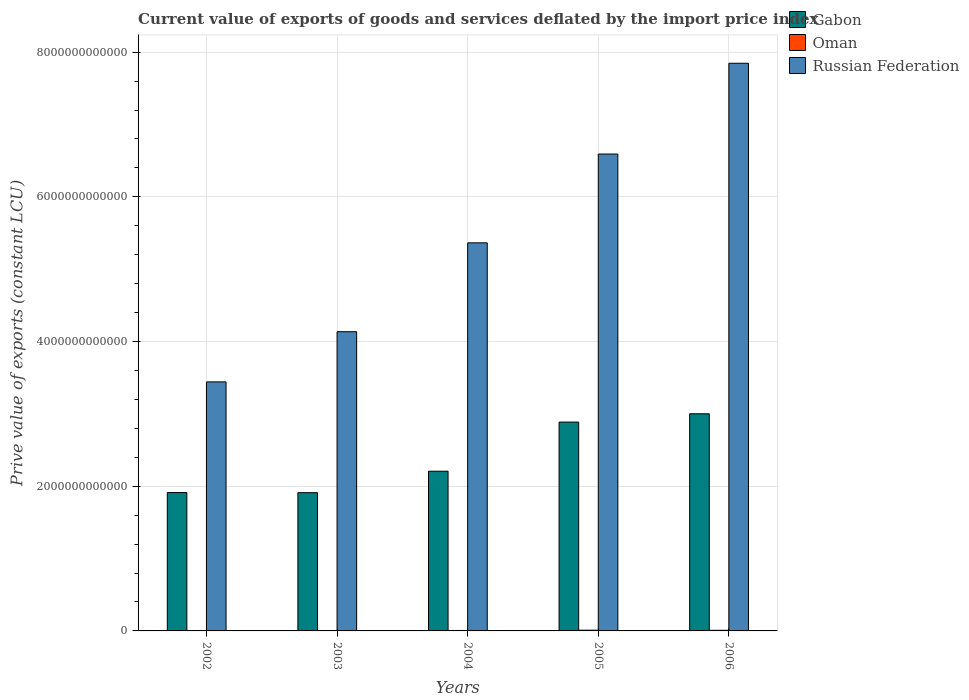How many different coloured bars are there?
Ensure brevity in your answer.  3. Are the number of bars per tick equal to the number of legend labels?
Your answer should be compact. Yes. Are the number of bars on each tick of the X-axis equal?
Your response must be concise. Yes. How many bars are there on the 1st tick from the left?
Your answer should be very brief. 3. What is the label of the 1st group of bars from the left?
Your answer should be compact. 2002. In how many cases, is the number of bars for a given year not equal to the number of legend labels?
Keep it short and to the point. 0. What is the prive value of exports in Russian Federation in 2004?
Your answer should be compact. 5.36e+12. Across all years, what is the maximum prive value of exports in Oman?
Offer a very short reply. 9.95e+09. Across all years, what is the minimum prive value of exports in Gabon?
Your answer should be very brief. 1.91e+12. In which year was the prive value of exports in Gabon maximum?
Your answer should be compact. 2006. What is the total prive value of exports in Gabon in the graph?
Offer a terse response. 1.19e+13. What is the difference between the prive value of exports in Russian Federation in 2002 and that in 2006?
Your answer should be very brief. -4.40e+12. What is the difference between the prive value of exports in Oman in 2005 and the prive value of exports in Gabon in 2002?
Your response must be concise. -1.90e+12. What is the average prive value of exports in Oman per year?
Your response must be concise. 7.17e+09. In the year 2003, what is the difference between the prive value of exports in Oman and prive value of exports in Gabon?
Ensure brevity in your answer.  -1.91e+12. What is the ratio of the prive value of exports in Oman in 2002 to that in 2005?
Offer a terse response. 0.53. Is the prive value of exports in Gabon in 2003 less than that in 2004?
Your answer should be very brief. Yes. Is the difference between the prive value of exports in Oman in 2003 and 2005 greater than the difference between the prive value of exports in Gabon in 2003 and 2005?
Offer a terse response. Yes. What is the difference between the highest and the second highest prive value of exports in Oman?
Give a very brief answer. 1.43e+09. What is the difference between the highest and the lowest prive value of exports in Gabon?
Provide a succinct answer. 1.09e+12. In how many years, is the prive value of exports in Gabon greater than the average prive value of exports in Gabon taken over all years?
Your answer should be compact. 2. What does the 3rd bar from the left in 2006 represents?
Give a very brief answer. Russian Federation. What does the 2nd bar from the right in 2002 represents?
Your response must be concise. Oman. Is it the case that in every year, the sum of the prive value of exports in Russian Federation and prive value of exports in Gabon is greater than the prive value of exports in Oman?
Make the answer very short. Yes. How many bars are there?
Provide a short and direct response. 15. What is the difference between two consecutive major ticks on the Y-axis?
Your answer should be very brief. 2.00e+12. Does the graph contain any zero values?
Your answer should be compact. No. Does the graph contain grids?
Make the answer very short. Yes. Where does the legend appear in the graph?
Your answer should be very brief. Top right. What is the title of the graph?
Provide a short and direct response. Current value of exports of goods and services deflated by the import price index. What is the label or title of the Y-axis?
Your answer should be compact. Prive value of exports (constant LCU). What is the Prive value of exports (constant LCU) in Gabon in 2002?
Keep it short and to the point. 1.91e+12. What is the Prive value of exports (constant LCU) in Oman in 2002?
Your answer should be compact. 5.25e+09. What is the Prive value of exports (constant LCU) of Russian Federation in 2002?
Offer a terse response. 3.44e+12. What is the Prive value of exports (constant LCU) in Gabon in 2003?
Your response must be concise. 1.91e+12. What is the Prive value of exports (constant LCU) in Oman in 2003?
Offer a terse response. 5.76e+09. What is the Prive value of exports (constant LCU) of Russian Federation in 2003?
Offer a terse response. 4.14e+12. What is the Prive value of exports (constant LCU) in Gabon in 2004?
Offer a terse response. 2.21e+12. What is the Prive value of exports (constant LCU) of Oman in 2004?
Keep it short and to the point. 6.38e+09. What is the Prive value of exports (constant LCU) of Russian Federation in 2004?
Provide a short and direct response. 5.36e+12. What is the Prive value of exports (constant LCU) in Gabon in 2005?
Your answer should be very brief. 2.89e+12. What is the Prive value of exports (constant LCU) in Oman in 2005?
Ensure brevity in your answer.  9.95e+09. What is the Prive value of exports (constant LCU) of Russian Federation in 2005?
Your answer should be very brief. 6.59e+12. What is the Prive value of exports (constant LCU) in Gabon in 2006?
Provide a succinct answer. 3.00e+12. What is the Prive value of exports (constant LCU) of Oman in 2006?
Keep it short and to the point. 8.52e+09. What is the Prive value of exports (constant LCU) of Russian Federation in 2006?
Your answer should be very brief. 7.85e+12. Across all years, what is the maximum Prive value of exports (constant LCU) of Gabon?
Keep it short and to the point. 3.00e+12. Across all years, what is the maximum Prive value of exports (constant LCU) of Oman?
Your answer should be compact. 9.95e+09. Across all years, what is the maximum Prive value of exports (constant LCU) in Russian Federation?
Offer a very short reply. 7.85e+12. Across all years, what is the minimum Prive value of exports (constant LCU) in Gabon?
Keep it short and to the point. 1.91e+12. Across all years, what is the minimum Prive value of exports (constant LCU) of Oman?
Provide a short and direct response. 5.25e+09. Across all years, what is the minimum Prive value of exports (constant LCU) of Russian Federation?
Keep it short and to the point. 3.44e+12. What is the total Prive value of exports (constant LCU) of Gabon in the graph?
Your answer should be compact. 1.19e+13. What is the total Prive value of exports (constant LCU) of Oman in the graph?
Your answer should be very brief. 3.59e+1. What is the total Prive value of exports (constant LCU) in Russian Federation in the graph?
Your answer should be compact. 2.74e+13. What is the difference between the Prive value of exports (constant LCU) of Gabon in 2002 and that in 2003?
Your answer should be very brief. 1.37e+09. What is the difference between the Prive value of exports (constant LCU) of Oman in 2002 and that in 2003?
Provide a short and direct response. -5.11e+08. What is the difference between the Prive value of exports (constant LCU) of Russian Federation in 2002 and that in 2003?
Your answer should be compact. -6.94e+11. What is the difference between the Prive value of exports (constant LCU) in Gabon in 2002 and that in 2004?
Your response must be concise. -2.95e+11. What is the difference between the Prive value of exports (constant LCU) in Oman in 2002 and that in 2004?
Provide a short and direct response. -1.13e+09. What is the difference between the Prive value of exports (constant LCU) of Russian Federation in 2002 and that in 2004?
Keep it short and to the point. -1.92e+12. What is the difference between the Prive value of exports (constant LCU) of Gabon in 2002 and that in 2005?
Give a very brief answer. -9.75e+11. What is the difference between the Prive value of exports (constant LCU) in Oman in 2002 and that in 2005?
Provide a short and direct response. -4.70e+09. What is the difference between the Prive value of exports (constant LCU) in Russian Federation in 2002 and that in 2005?
Ensure brevity in your answer.  -3.15e+12. What is the difference between the Prive value of exports (constant LCU) in Gabon in 2002 and that in 2006?
Offer a terse response. -1.09e+12. What is the difference between the Prive value of exports (constant LCU) of Oman in 2002 and that in 2006?
Provide a succinct answer. -3.27e+09. What is the difference between the Prive value of exports (constant LCU) in Russian Federation in 2002 and that in 2006?
Offer a very short reply. -4.40e+12. What is the difference between the Prive value of exports (constant LCU) of Gabon in 2003 and that in 2004?
Your answer should be very brief. -2.97e+11. What is the difference between the Prive value of exports (constant LCU) of Oman in 2003 and that in 2004?
Ensure brevity in your answer.  -6.16e+08. What is the difference between the Prive value of exports (constant LCU) of Russian Federation in 2003 and that in 2004?
Offer a terse response. -1.23e+12. What is the difference between the Prive value of exports (constant LCU) in Gabon in 2003 and that in 2005?
Ensure brevity in your answer.  -9.76e+11. What is the difference between the Prive value of exports (constant LCU) of Oman in 2003 and that in 2005?
Keep it short and to the point. -4.19e+09. What is the difference between the Prive value of exports (constant LCU) in Russian Federation in 2003 and that in 2005?
Your answer should be very brief. -2.46e+12. What is the difference between the Prive value of exports (constant LCU) in Gabon in 2003 and that in 2006?
Make the answer very short. -1.09e+12. What is the difference between the Prive value of exports (constant LCU) of Oman in 2003 and that in 2006?
Give a very brief answer. -2.75e+09. What is the difference between the Prive value of exports (constant LCU) of Russian Federation in 2003 and that in 2006?
Give a very brief answer. -3.71e+12. What is the difference between the Prive value of exports (constant LCU) in Gabon in 2004 and that in 2005?
Provide a short and direct response. -6.79e+11. What is the difference between the Prive value of exports (constant LCU) of Oman in 2004 and that in 2005?
Your response must be concise. -3.57e+09. What is the difference between the Prive value of exports (constant LCU) in Russian Federation in 2004 and that in 2005?
Your answer should be compact. -1.23e+12. What is the difference between the Prive value of exports (constant LCU) of Gabon in 2004 and that in 2006?
Offer a very short reply. -7.94e+11. What is the difference between the Prive value of exports (constant LCU) of Oman in 2004 and that in 2006?
Your response must be concise. -2.14e+09. What is the difference between the Prive value of exports (constant LCU) of Russian Federation in 2004 and that in 2006?
Ensure brevity in your answer.  -2.48e+12. What is the difference between the Prive value of exports (constant LCU) of Gabon in 2005 and that in 2006?
Your answer should be very brief. -1.15e+11. What is the difference between the Prive value of exports (constant LCU) of Oman in 2005 and that in 2006?
Keep it short and to the point. 1.43e+09. What is the difference between the Prive value of exports (constant LCU) of Russian Federation in 2005 and that in 2006?
Keep it short and to the point. -1.25e+12. What is the difference between the Prive value of exports (constant LCU) of Gabon in 2002 and the Prive value of exports (constant LCU) of Oman in 2003?
Offer a terse response. 1.91e+12. What is the difference between the Prive value of exports (constant LCU) in Gabon in 2002 and the Prive value of exports (constant LCU) in Russian Federation in 2003?
Ensure brevity in your answer.  -2.22e+12. What is the difference between the Prive value of exports (constant LCU) in Oman in 2002 and the Prive value of exports (constant LCU) in Russian Federation in 2003?
Offer a very short reply. -4.13e+12. What is the difference between the Prive value of exports (constant LCU) in Gabon in 2002 and the Prive value of exports (constant LCU) in Oman in 2004?
Keep it short and to the point. 1.91e+12. What is the difference between the Prive value of exports (constant LCU) in Gabon in 2002 and the Prive value of exports (constant LCU) in Russian Federation in 2004?
Provide a short and direct response. -3.45e+12. What is the difference between the Prive value of exports (constant LCU) of Oman in 2002 and the Prive value of exports (constant LCU) of Russian Federation in 2004?
Give a very brief answer. -5.36e+12. What is the difference between the Prive value of exports (constant LCU) in Gabon in 2002 and the Prive value of exports (constant LCU) in Oman in 2005?
Make the answer very short. 1.90e+12. What is the difference between the Prive value of exports (constant LCU) in Gabon in 2002 and the Prive value of exports (constant LCU) in Russian Federation in 2005?
Your response must be concise. -4.68e+12. What is the difference between the Prive value of exports (constant LCU) in Oman in 2002 and the Prive value of exports (constant LCU) in Russian Federation in 2005?
Offer a very short reply. -6.59e+12. What is the difference between the Prive value of exports (constant LCU) in Gabon in 2002 and the Prive value of exports (constant LCU) in Oman in 2006?
Your answer should be compact. 1.90e+12. What is the difference between the Prive value of exports (constant LCU) of Gabon in 2002 and the Prive value of exports (constant LCU) of Russian Federation in 2006?
Provide a short and direct response. -5.93e+12. What is the difference between the Prive value of exports (constant LCU) in Oman in 2002 and the Prive value of exports (constant LCU) in Russian Federation in 2006?
Your answer should be compact. -7.84e+12. What is the difference between the Prive value of exports (constant LCU) of Gabon in 2003 and the Prive value of exports (constant LCU) of Oman in 2004?
Offer a terse response. 1.90e+12. What is the difference between the Prive value of exports (constant LCU) of Gabon in 2003 and the Prive value of exports (constant LCU) of Russian Federation in 2004?
Keep it short and to the point. -3.45e+12. What is the difference between the Prive value of exports (constant LCU) in Oman in 2003 and the Prive value of exports (constant LCU) in Russian Federation in 2004?
Give a very brief answer. -5.36e+12. What is the difference between the Prive value of exports (constant LCU) of Gabon in 2003 and the Prive value of exports (constant LCU) of Oman in 2005?
Your answer should be compact. 1.90e+12. What is the difference between the Prive value of exports (constant LCU) in Gabon in 2003 and the Prive value of exports (constant LCU) in Russian Federation in 2005?
Your answer should be very brief. -4.68e+12. What is the difference between the Prive value of exports (constant LCU) in Oman in 2003 and the Prive value of exports (constant LCU) in Russian Federation in 2005?
Provide a short and direct response. -6.59e+12. What is the difference between the Prive value of exports (constant LCU) of Gabon in 2003 and the Prive value of exports (constant LCU) of Oman in 2006?
Keep it short and to the point. 1.90e+12. What is the difference between the Prive value of exports (constant LCU) of Gabon in 2003 and the Prive value of exports (constant LCU) of Russian Federation in 2006?
Offer a terse response. -5.94e+12. What is the difference between the Prive value of exports (constant LCU) in Oman in 2003 and the Prive value of exports (constant LCU) in Russian Federation in 2006?
Your answer should be compact. -7.84e+12. What is the difference between the Prive value of exports (constant LCU) in Gabon in 2004 and the Prive value of exports (constant LCU) in Oman in 2005?
Your answer should be compact. 2.20e+12. What is the difference between the Prive value of exports (constant LCU) in Gabon in 2004 and the Prive value of exports (constant LCU) in Russian Federation in 2005?
Keep it short and to the point. -4.38e+12. What is the difference between the Prive value of exports (constant LCU) in Oman in 2004 and the Prive value of exports (constant LCU) in Russian Federation in 2005?
Give a very brief answer. -6.59e+12. What is the difference between the Prive value of exports (constant LCU) in Gabon in 2004 and the Prive value of exports (constant LCU) in Oman in 2006?
Give a very brief answer. 2.20e+12. What is the difference between the Prive value of exports (constant LCU) in Gabon in 2004 and the Prive value of exports (constant LCU) in Russian Federation in 2006?
Make the answer very short. -5.64e+12. What is the difference between the Prive value of exports (constant LCU) in Oman in 2004 and the Prive value of exports (constant LCU) in Russian Federation in 2006?
Give a very brief answer. -7.84e+12. What is the difference between the Prive value of exports (constant LCU) of Gabon in 2005 and the Prive value of exports (constant LCU) of Oman in 2006?
Offer a very short reply. 2.88e+12. What is the difference between the Prive value of exports (constant LCU) of Gabon in 2005 and the Prive value of exports (constant LCU) of Russian Federation in 2006?
Make the answer very short. -4.96e+12. What is the difference between the Prive value of exports (constant LCU) of Oman in 2005 and the Prive value of exports (constant LCU) of Russian Federation in 2006?
Make the answer very short. -7.84e+12. What is the average Prive value of exports (constant LCU) of Gabon per year?
Your response must be concise. 2.38e+12. What is the average Prive value of exports (constant LCU) of Oman per year?
Provide a short and direct response. 7.17e+09. What is the average Prive value of exports (constant LCU) in Russian Federation per year?
Offer a terse response. 5.48e+12. In the year 2002, what is the difference between the Prive value of exports (constant LCU) in Gabon and Prive value of exports (constant LCU) in Oman?
Ensure brevity in your answer.  1.91e+12. In the year 2002, what is the difference between the Prive value of exports (constant LCU) of Gabon and Prive value of exports (constant LCU) of Russian Federation?
Ensure brevity in your answer.  -1.53e+12. In the year 2002, what is the difference between the Prive value of exports (constant LCU) of Oman and Prive value of exports (constant LCU) of Russian Federation?
Keep it short and to the point. -3.44e+12. In the year 2003, what is the difference between the Prive value of exports (constant LCU) in Gabon and Prive value of exports (constant LCU) in Oman?
Your answer should be very brief. 1.91e+12. In the year 2003, what is the difference between the Prive value of exports (constant LCU) of Gabon and Prive value of exports (constant LCU) of Russian Federation?
Give a very brief answer. -2.22e+12. In the year 2003, what is the difference between the Prive value of exports (constant LCU) in Oman and Prive value of exports (constant LCU) in Russian Federation?
Give a very brief answer. -4.13e+12. In the year 2004, what is the difference between the Prive value of exports (constant LCU) of Gabon and Prive value of exports (constant LCU) of Oman?
Offer a terse response. 2.20e+12. In the year 2004, what is the difference between the Prive value of exports (constant LCU) of Gabon and Prive value of exports (constant LCU) of Russian Federation?
Offer a very short reply. -3.16e+12. In the year 2004, what is the difference between the Prive value of exports (constant LCU) in Oman and Prive value of exports (constant LCU) in Russian Federation?
Offer a very short reply. -5.36e+12. In the year 2005, what is the difference between the Prive value of exports (constant LCU) in Gabon and Prive value of exports (constant LCU) in Oman?
Provide a succinct answer. 2.88e+12. In the year 2005, what is the difference between the Prive value of exports (constant LCU) in Gabon and Prive value of exports (constant LCU) in Russian Federation?
Provide a succinct answer. -3.71e+12. In the year 2005, what is the difference between the Prive value of exports (constant LCU) in Oman and Prive value of exports (constant LCU) in Russian Federation?
Keep it short and to the point. -6.58e+12. In the year 2006, what is the difference between the Prive value of exports (constant LCU) in Gabon and Prive value of exports (constant LCU) in Oman?
Provide a short and direct response. 2.99e+12. In the year 2006, what is the difference between the Prive value of exports (constant LCU) of Gabon and Prive value of exports (constant LCU) of Russian Federation?
Offer a very short reply. -4.84e+12. In the year 2006, what is the difference between the Prive value of exports (constant LCU) in Oman and Prive value of exports (constant LCU) in Russian Federation?
Give a very brief answer. -7.84e+12. What is the ratio of the Prive value of exports (constant LCU) in Gabon in 2002 to that in 2003?
Provide a short and direct response. 1. What is the ratio of the Prive value of exports (constant LCU) of Oman in 2002 to that in 2003?
Make the answer very short. 0.91. What is the ratio of the Prive value of exports (constant LCU) in Russian Federation in 2002 to that in 2003?
Offer a very short reply. 0.83. What is the ratio of the Prive value of exports (constant LCU) in Gabon in 2002 to that in 2004?
Make the answer very short. 0.87. What is the ratio of the Prive value of exports (constant LCU) of Oman in 2002 to that in 2004?
Offer a very short reply. 0.82. What is the ratio of the Prive value of exports (constant LCU) in Russian Federation in 2002 to that in 2004?
Give a very brief answer. 0.64. What is the ratio of the Prive value of exports (constant LCU) in Gabon in 2002 to that in 2005?
Your answer should be very brief. 0.66. What is the ratio of the Prive value of exports (constant LCU) of Oman in 2002 to that in 2005?
Provide a succinct answer. 0.53. What is the ratio of the Prive value of exports (constant LCU) in Russian Federation in 2002 to that in 2005?
Provide a succinct answer. 0.52. What is the ratio of the Prive value of exports (constant LCU) in Gabon in 2002 to that in 2006?
Give a very brief answer. 0.64. What is the ratio of the Prive value of exports (constant LCU) of Oman in 2002 to that in 2006?
Your answer should be very brief. 0.62. What is the ratio of the Prive value of exports (constant LCU) in Russian Federation in 2002 to that in 2006?
Ensure brevity in your answer.  0.44. What is the ratio of the Prive value of exports (constant LCU) in Gabon in 2003 to that in 2004?
Keep it short and to the point. 0.87. What is the ratio of the Prive value of exports (constant LCU) of Oman in 2003 to that in 2004?
Offer a terse response. 0.9. What is the ratio of the Prive value of exports (constant LCU) of Russian Federation in 2003 to that in 2004?
Offer a terse response. 0.77. What is the ratio of the Prive value of exports (constant LCU) of Gabon in 2003 to that in 2005?
Offer a very short reply. 0.66. What is the ratio of the Prive value of exports (constant LCU) of Oman in 2003 to that in 2005?
Provide a short and direct response. 0.58. What is the ratio of the Prive value of exports (constant LCU) of Russian Federation in 2003 to that in 2005?
Make the answer very short. 0.63. What is the ratio of the Prive value of exports (constant LCU) of Gabon in 2003 to that in 2006?
Ensure brevity in your answer.  0.64. What is the ratio of the Prive value of exports (constant LCU) in Oman in 2003 to that in 2006?
Provide a succinct answer. 0.68. What is the ratio of the Prive value of exports (constant LCU) of Russian Federation in 2003 to that in 2006?
Keep it short and to the point. 0.53. What is the ratio of the Prive value of exports (constant LCU) of Gabon in 2004 to that in 2005?
Provide a short and direct response. 0.76. What is the ratio of the Prive value of exports (constant LCU) in Oman in 2004 to that in 2005?
Your response must be concise. 0.64. What is the ratio of the Prive value of exports (constant LCU) of Russian Federation in 2004 to that in 2005?
Your answer should be compact. 0.81. What is the ratio of the Prive value of exports (constant LCU) in Gabon in 2004 to that in 2006?
Provide a succinct answer. 0.74. What is the ratio of the Prive value of exports (constant LCU) of Oman in 2004 to that in 2006?
Give a very brief answer. 0.75. What is the ratio of the Prive value of exports (constant LCU) of Russian Federation in 2004 to that in 2006?
Keep it short and to the point. 0.68. What is the ratio of the Prive value of exports (constant LCU) of Gabon in 2005 to that in 2006?
Provide a succinct answer. 0.96. What is the ratio of the Prive value of exports (constant LCU) in Oman in 2005 to that in 2006?
Provide a succinct answer. 1.17. What is the ratio of the Prive value of exports (constant LCU) in Russian Federation in 2005 to that in 2006?
Provide a succinct answer. 0.84. What is the difference between the highest and the second highest Prive value of exports (constant LCU) of Gabon?
Provide a short and direct response. 1.15e+11. What is the difference between the highest and the second highest Prive value of exports (constant LCU) in Oman?
Your answer should be compact. 1.43e+09. What is the difference between the highest and the second highest Prive value of exports (constant LCU) in Russian Federation?
Provide a succinct answer. 1.25e+12. What is the difference between the highest and the lowest Prive value of exports (constant LCU) in Gabon?
Your answer should be compact. 1.09e+12. What is the difference between the highest and the lowest Prive value of exports (constant LCU) in Oman?
Make the answer very short. 4.70e+09. What is the difference between the highest and the lowest Prive value of exports (constant LCU) in Russian Federation?
Provide a short and direct response. 4.40e+12. 